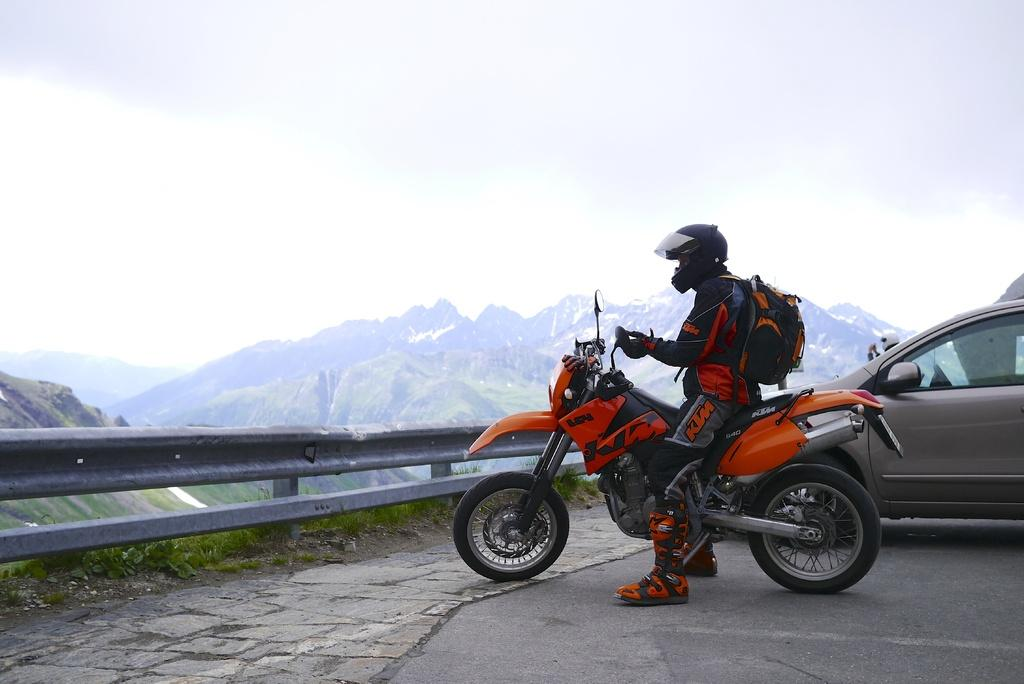What can be seen in the sky in the image? The sky with clouds is visible in the image. What type of natural feature is present in the image? There are hills in the image. What might be used to control traffic or restrict access in the image? Barriers are present in the image. What are the persons in the image doing? Persons are sitting on motor vehicles on the road. What type of art can be seen on the paper in the image? There is no paper or art present in the image. What type of farming equipment is visible in the image? There is no farming equipment, such as a plough, present in the image. 